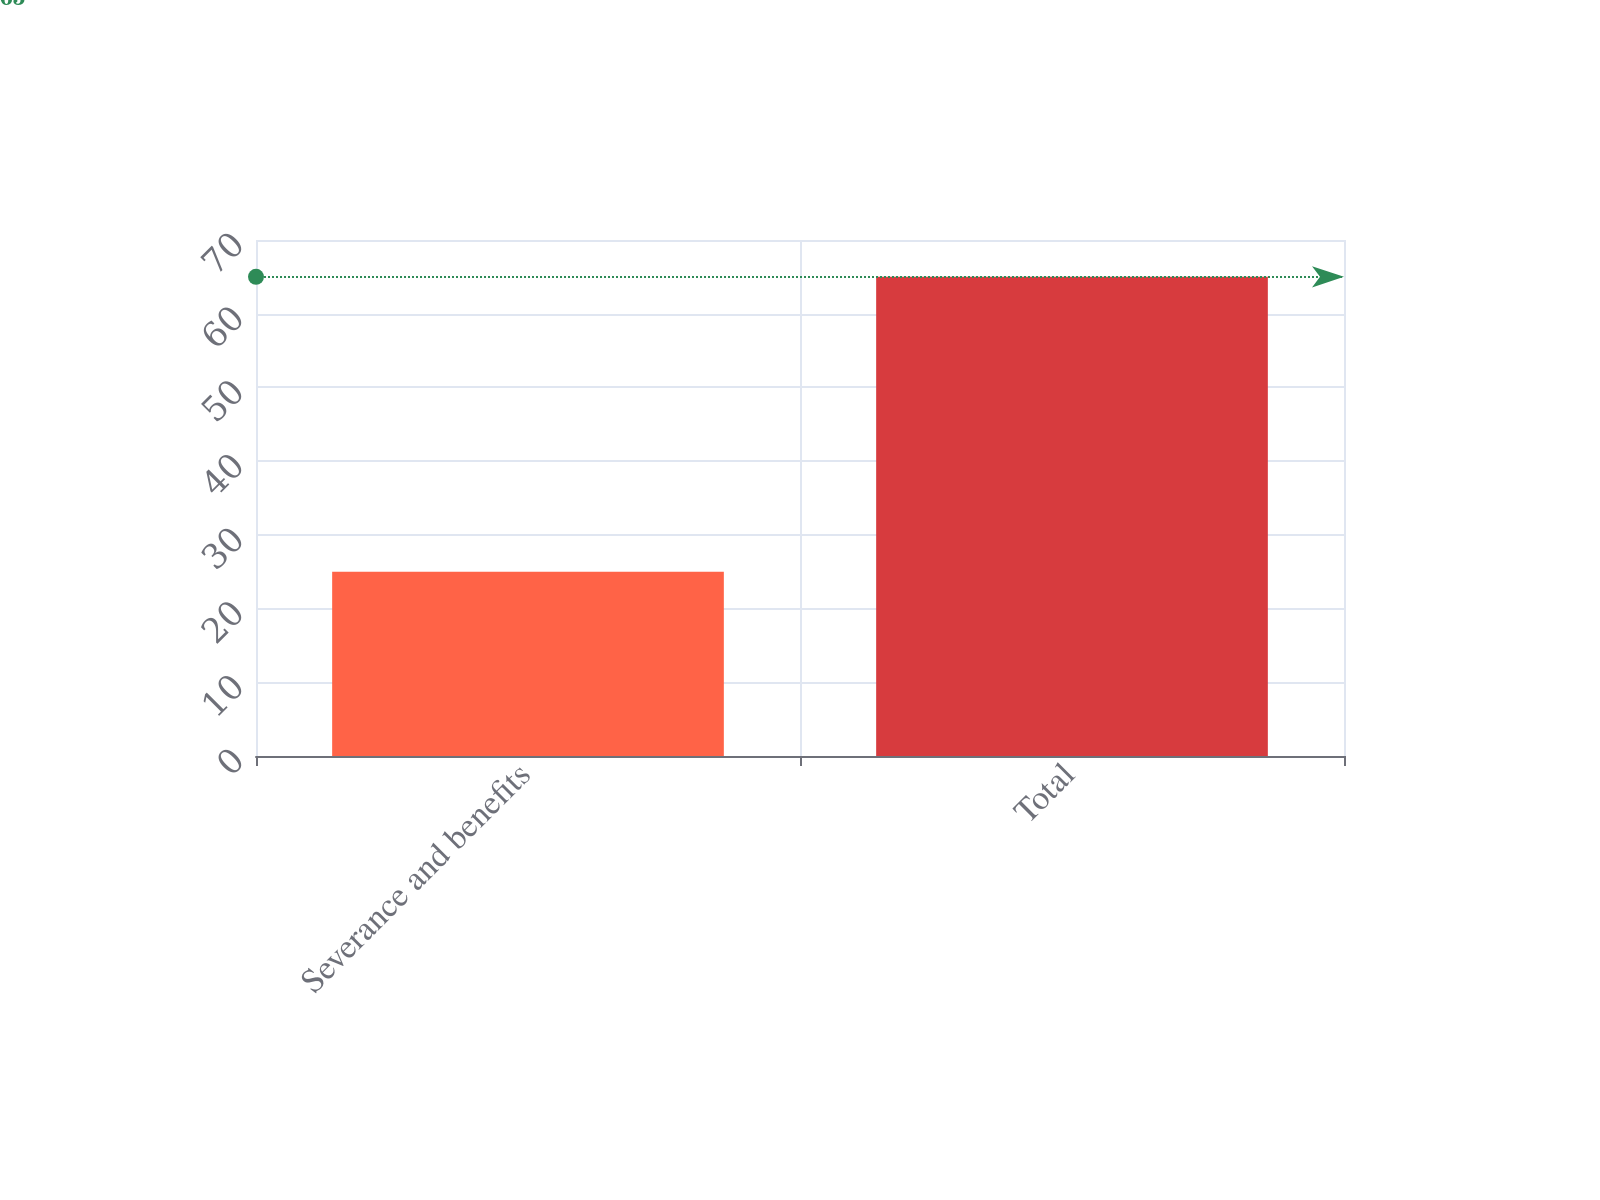Convert chart to OTSL. <chart><loc_0><loc_0><loc_500><loc_500><bar_chart><fcel>Severance and benefits<fcel>Total<nl><fcel>25<fcel>65<nl></chart> 